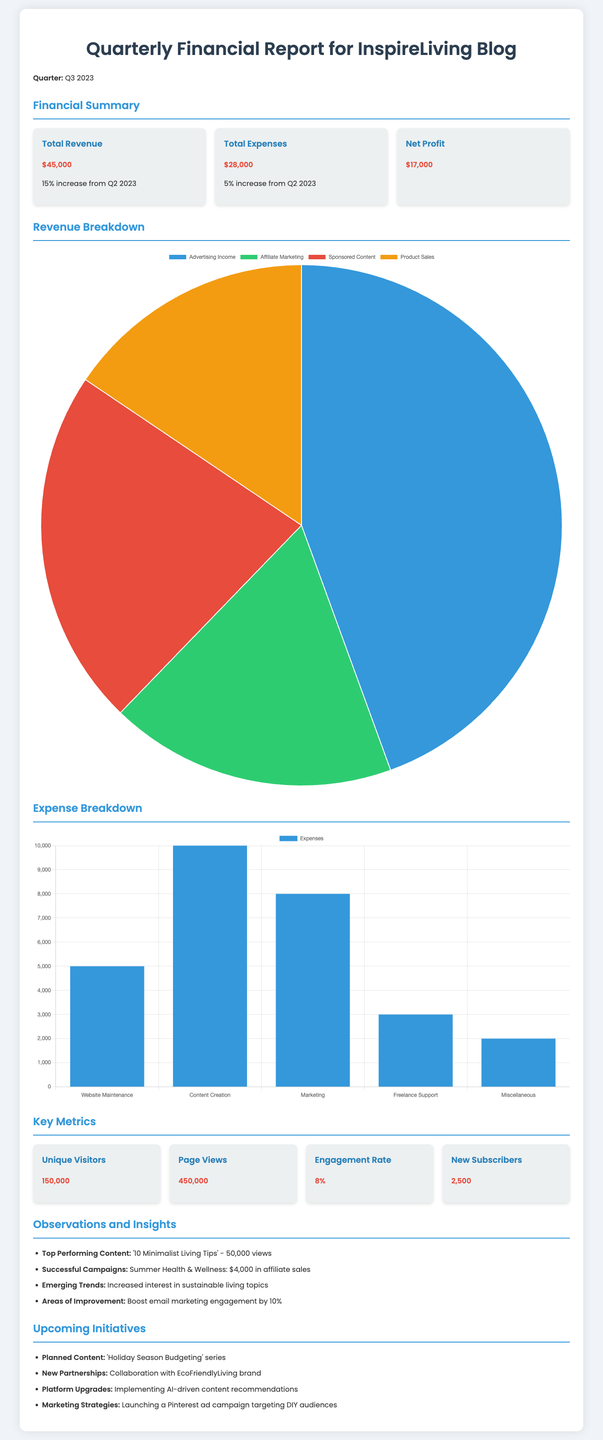What was the total revenue for Q3 2023? The total revenue is listed in the financial summary section as $45,000.
Answer: $45,000 What is the percentage increase in expenses from Q2 2023? The total expenses increased by 5% from Q2 2023 as stated in the financial summary.
Answer: 5% What is the net profit reported for Q3 2023? The document explicitly states that the net profit is $17,000.
Answer: $17,000 How many new subscribers were gained in Q3 2023? The report mentions that 2,500 new subscribers were acquired during Q3 2023.
Answer: 2,500 Which content was the top performing in terms of views? The document indicates that '10 Minimalist Living Tips' received 50,000 views, making it the top performer.
Answer: '10 Minimalist Living Tips' What is the total number of unique visitors reported? The document specifies that there were 150,000 unique visitors during Q3 2023.
Answer: 150,000 What is the expected focus for upcoming content mentioned in the initiatives section? The report outlines that the planned content focuses on a 'Holiday Season Budgeting' series.
Answer: 'Holiday Season Budgeting' Which marketing strategy is being launched as mentioned in the document? The document states that a Pinterest ad campaign targeting DIY audiences is being launched.
Answer: Pinterest ad campaign What is the engagement rate reported in the key metrics? The document lists the engagement rate as 8% in the key metrics section.
Answer: 8% 